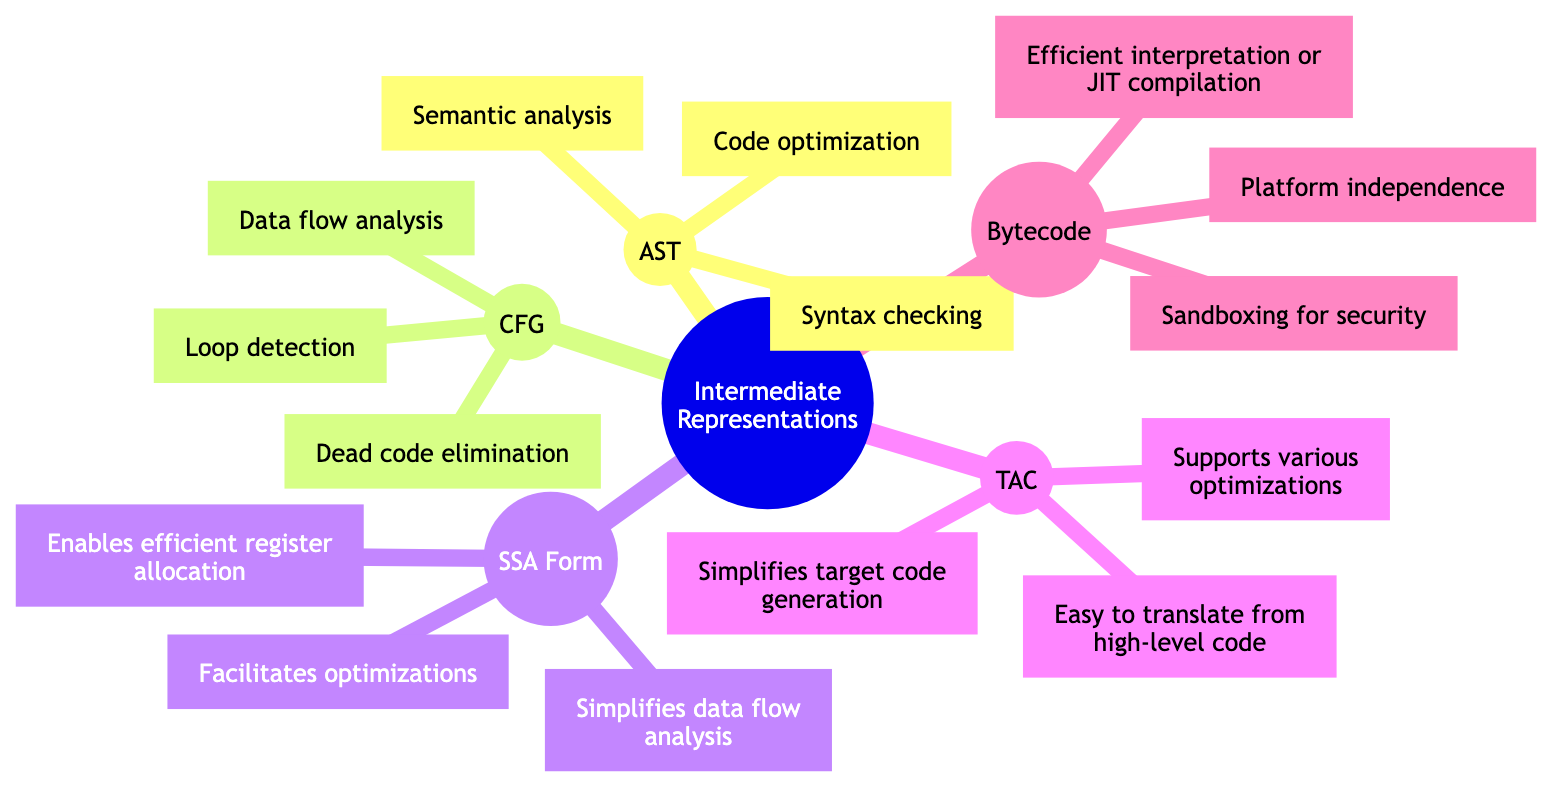What is the title of the mind map? The title of the mind map is explicitly stated at the root node, which indicates the main topic of the diagram.
Answer: Intermediate Representations in Compiler Design How many types of intermediate representations are shown in the diagram? The diagram displays five different types of intermediate representations, each represented as a separate node off the main root.
Answer: Five What is one of the uses of Abstract Syntax Tree? By looking at the node for Abstract Syntax Tree (AST), we can see multiple uses listed, so any one of these can be an answer. Specifically, “Syntax checking” is one of the listed uses.
Answer: Syntax checking Which intermediate representation is described as having a "property requiring each variable to be assigned exactly once"? The description of the Static Single Assignment (SSA) Form includes this specific property in its textual explanation.
Answer: Static Single Assignment Name one advantage of using Bytecode. Bytecode has several advantages listed in the diagram; one listed is "Platform independence," which indicates its functionality across different systems.
Answer: Platform independence What does Control Flow Graph allow for in program analysis? The Control Flow Graph (CFG) node shows various uses, and one prominent use is "Loop detection," which is crucial for understanding program execution flow.
Answer: Loop detection Which representation emphasizes "Easy to translate from high-level code"? The Three-Address Code (TAC) node explicitly mentions this advantage, highlighting its user-friendly nature in compiler design regarding translation.
Answer: Three-Address Code What is a common use shared between Control Flow Graph and Static Single Assignment Form? Both CFG and SSA are associated with data flow analysis, allowing the compiler to monitor the flow of data in programs, hence a shared use is present in both sections.
Answer: Data flow analysis Identify one of the important functionalities of SSA Form. The SSA Form's node states it "Facilitates optimizations," which showcases its role in improving code efficiency through various optimizations during compilation.
Answer: Facilitates optimizations 